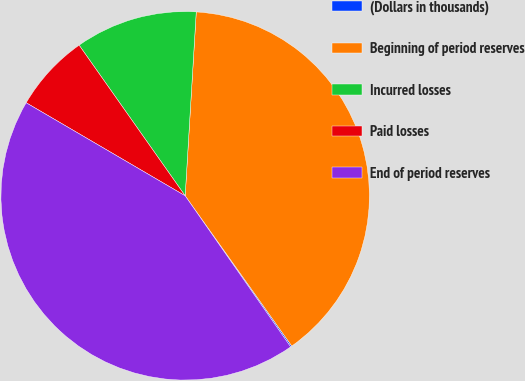Convert chart to OTSL. <chart><loc_0><loc_0><loc_500><loc_500><pie_chart><fcel>(Dollars in thousands)<fcel>Beginning of period reserves<fcel>Incurred losses<fcel>Paid losses<fcel>End of period reserves<nl><fcel>0.12%<fcel>39.22%<fcel>10.72%<fcel>6.81%<fcel>43.13%<nl></chart> 